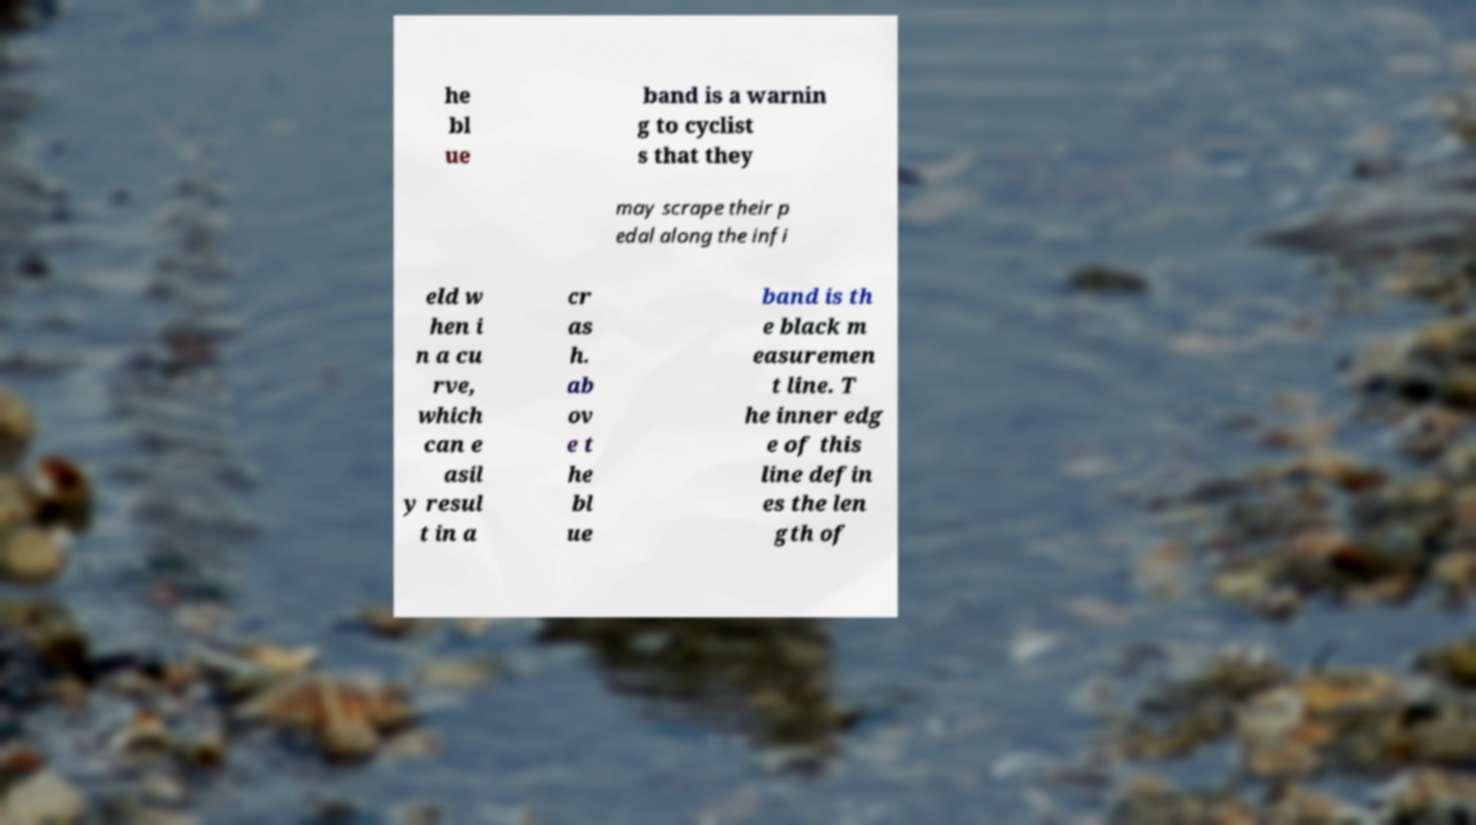Please read and relay the text visible in this image. What does it say? he bl ue band is a warnin g to cyclist s that they may scrape their p edal along the infi eld w hen i n a cu rve, which can e asil y resul t in a cr as h. ab ov e t he bl ue band is th e black m easuremen t line. T he inner edg e of this line defin es the len gth of 